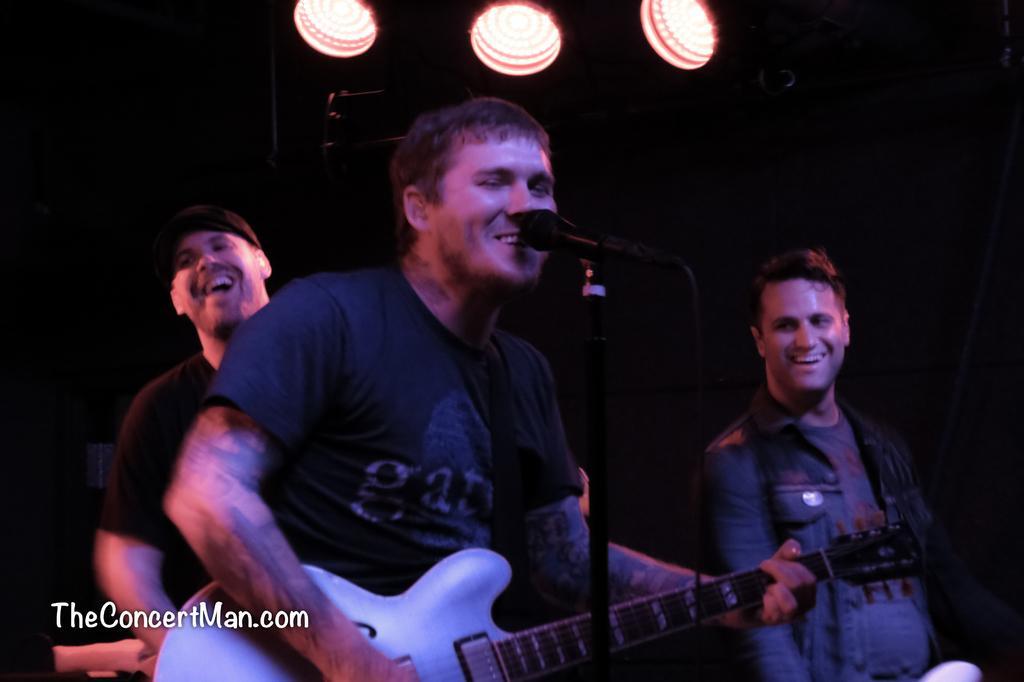In one or two sentences, can you explain what this image depicts? In this image i can see a person standing and holding a guitar, and there is a microphone in front of him. In the background i can see 2 other persons and few lights. 